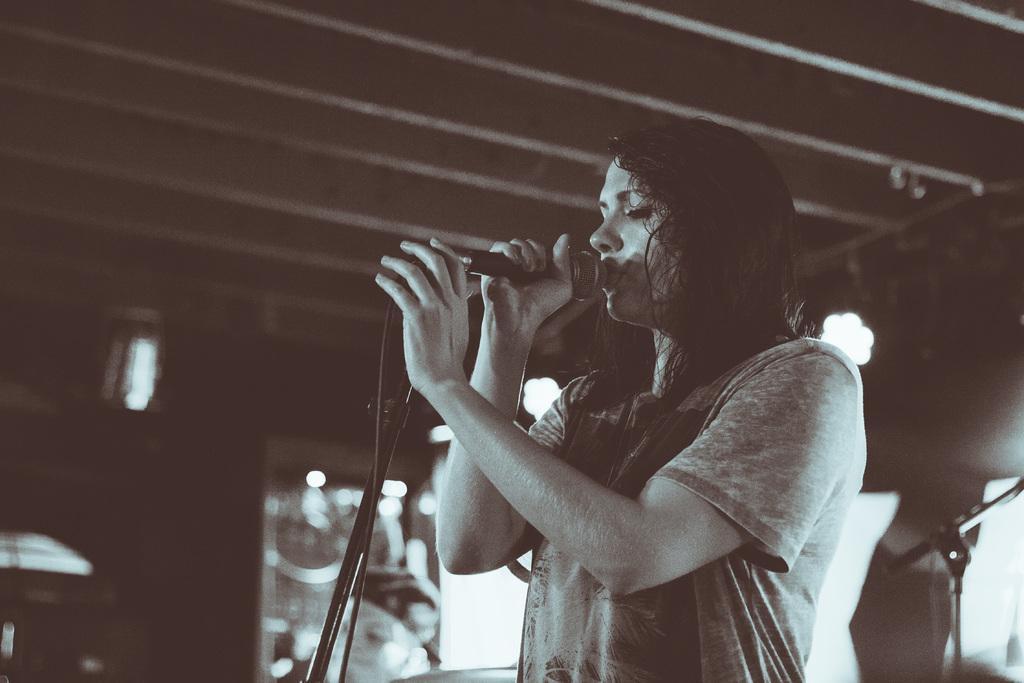Could you give a brief overview of what you see in this image? In the foreground of the image we can see a women holding a mic in her hands and singing. In the background of the image we can see ceiling and lights. 